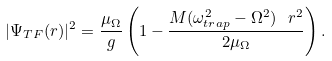<formula> <loc_0><loc_0><loc_500><loc_500>| \Psi _ { T F } ( { r } ) | ^ { 2 } = \frac { \mu _ { \Omega } } { g } \left ( 1 - \frac { M ( \omega _ { t r a p } ^ { 2 } - \Omega ^ { 2 } ) { \ r } ^ { 2 } } { 2 \mu _ { \Omega } } \right ) .</formula> 